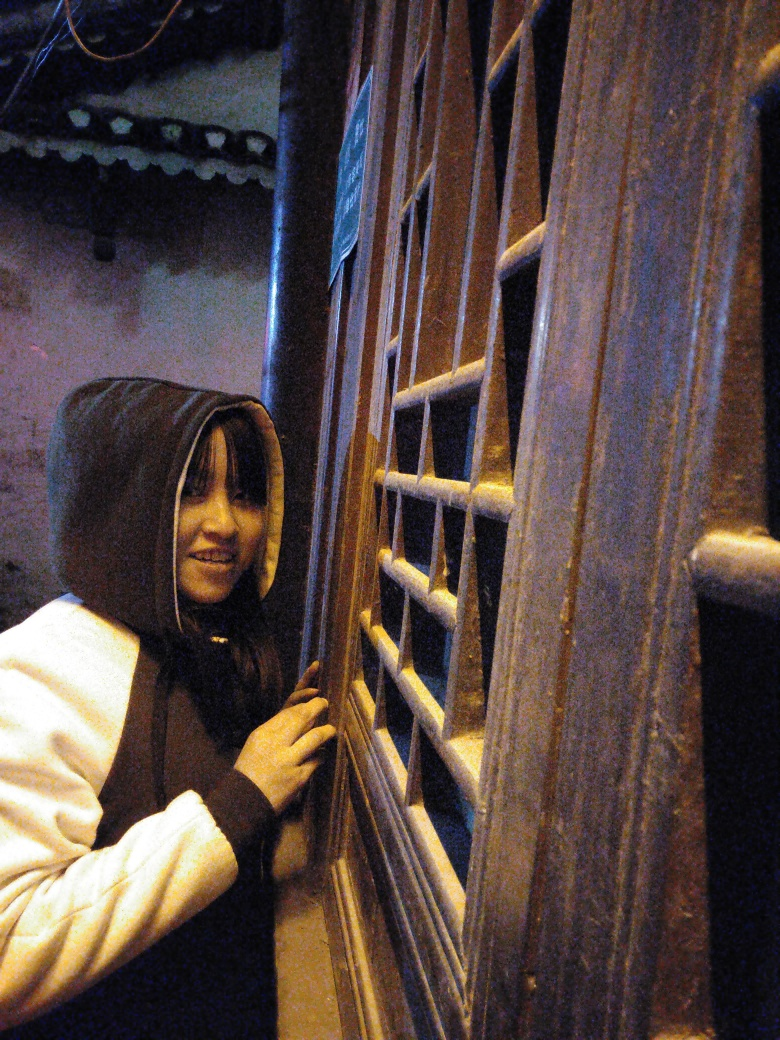What kind of mood does the lighting in this image evoke? The lighting in this image creates a mysterious and intimate mood, with shadows and a soft glow that could suggest a quiet, suspenseful moment. 